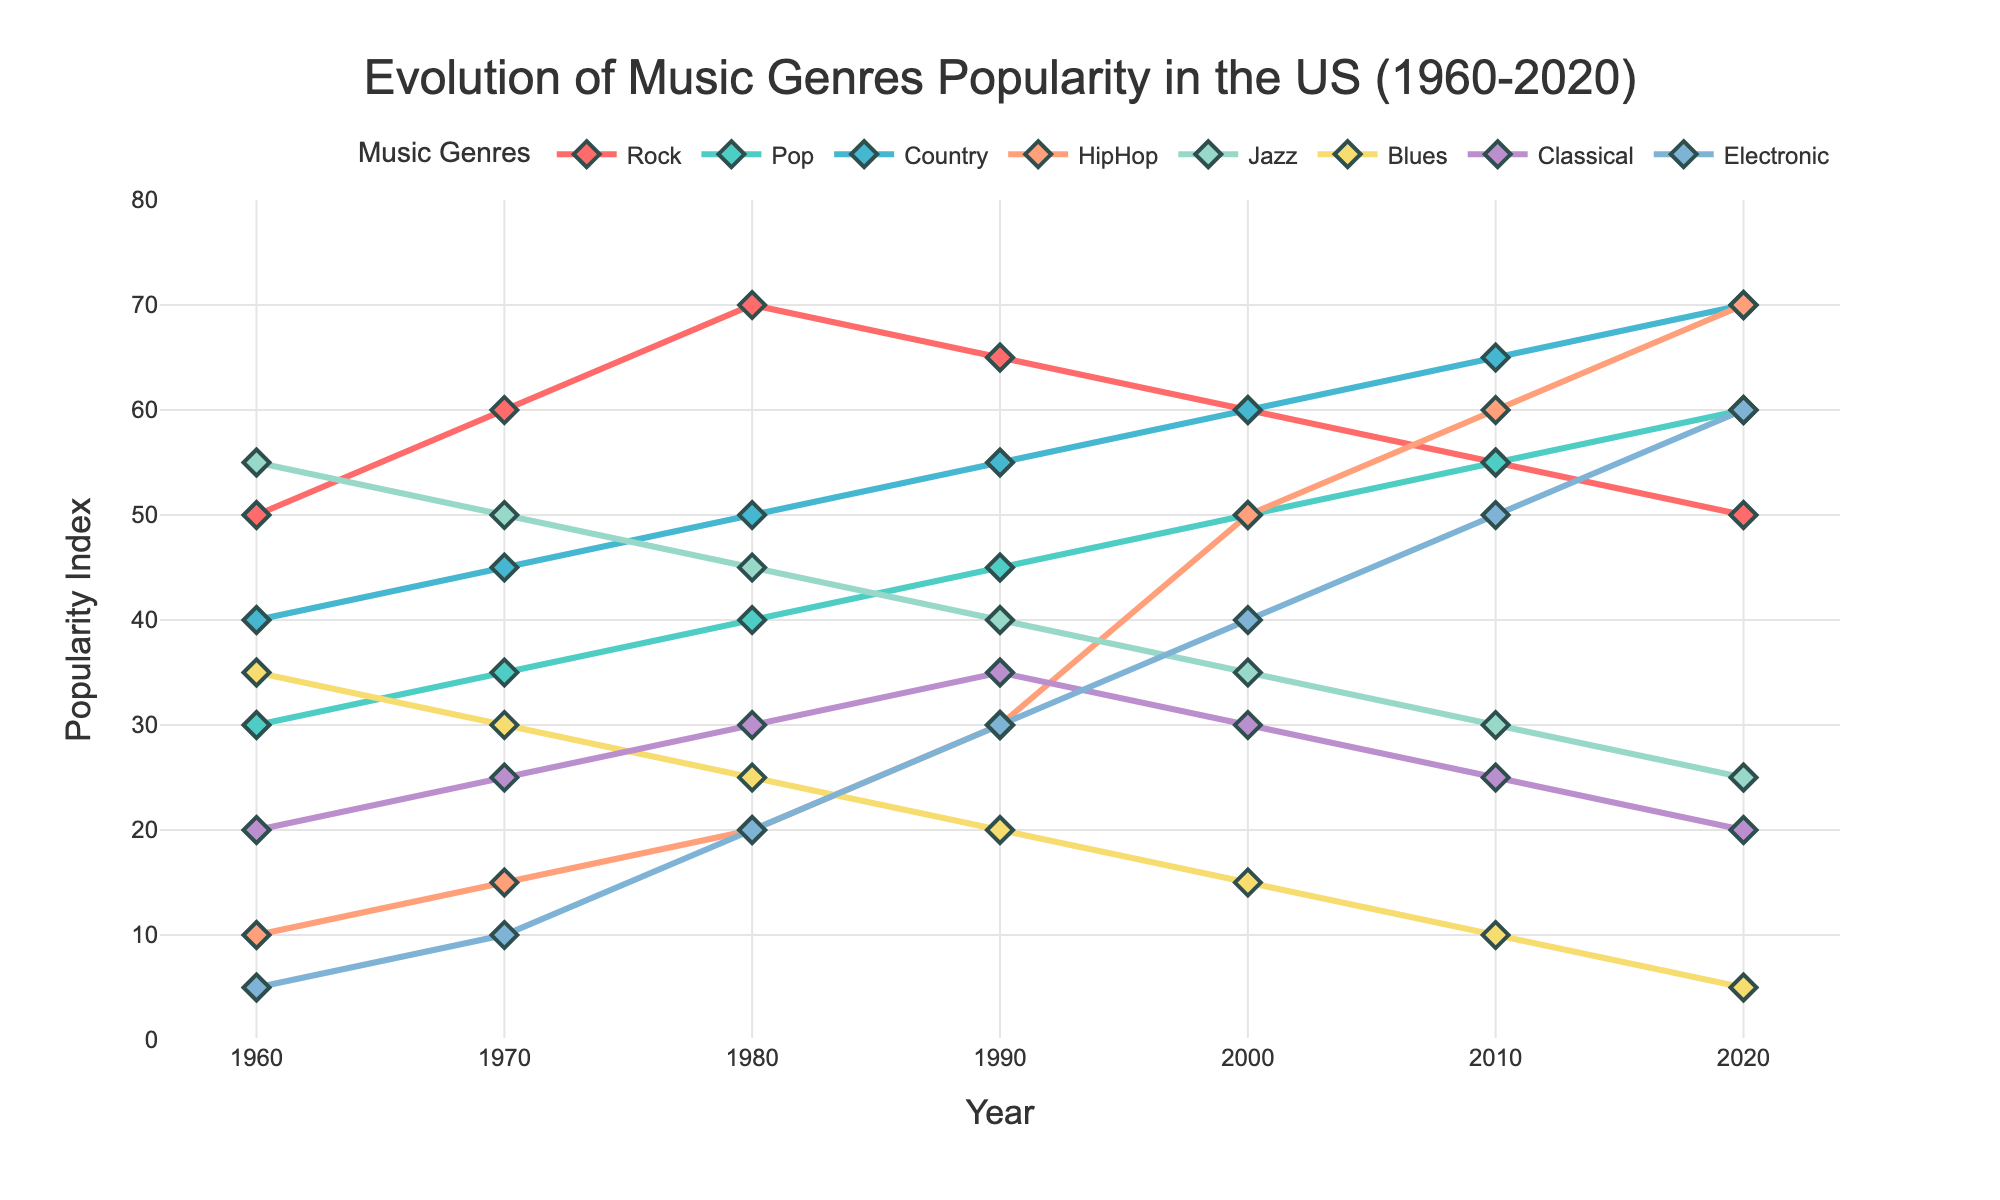What is the title of the plot? The title is usually located at the top of the plot. It summarizes the main point of the figure.
Answer: Evolution of Music Genres Popularity in the US (1960-2020) What does the x-axis represent? The x-axis runs horizontally at the bottom of the plot. Labels along it usually indicate the variable it represents.
Answer: Year Which genre had the highest popularity in 1960? Locate the year 1960 on the x-axis and then check the corresponding values for all genres to find the highest one.
Answer: Jazz How did the popularity of HipHop change from 1980 to 2000? Check the values of HipHop in 1980 and 2000 on the plot. Compare the two values to understand the trend over time.
Answer: Increased from 20 to 50 What's the trend in the popularity of Classical music from 1960 to 2020? Look at the line corresponding to Classical music and identify how it changes from the beginning to the end of the timeline.
Answer: Decreased Between which decades did Pop music see the most significant increase in popularity? Evaluate each decade's increase by finding the value differences and identify the largest one.
Answer: 2010 to 2020 Which genres' popularity decreased continuously from 1960 to 2020? Examine each genre's trend over the entire timeline to see which ones show a continuously declining pattern.
Answer: Jazz, Blues, Classical In what year did Rock music reach its peak popularity? Find the maximum value on the plot for Rock music and note the corresponding year.
Answer: 1980 Compare the popularity of Electronic music and Country music in 2020. Which one is more popular? Find the values for Electronic and Country genres in 2020 and see which is higher.
Answer: Electronic Is there any genre that surpassed Pop music in popularity between 1960 and 2020? If yes, which one(s)? Compare Pop music trends with other genres over the years and identify if any surpass Pop music at any point.
Answer: Yes, Country Which genre has the most consistent trend from 1960 to 2020? Look at all the genres' lines and identify which one has the least variation or most consistent slope.
Answer: Country 